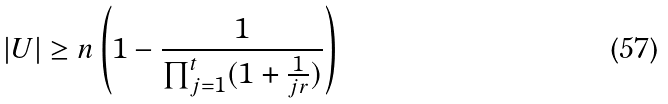Convert formula to latex. <formula><loc_0><loc_0><loc_500><loc_500>| U | \geq n \left ( 1 - \frac { 1 } { \prod _ { j = 1 } ^ { t } ( 1 + \frac { 1 } { j r } ) } \right )</formula> 